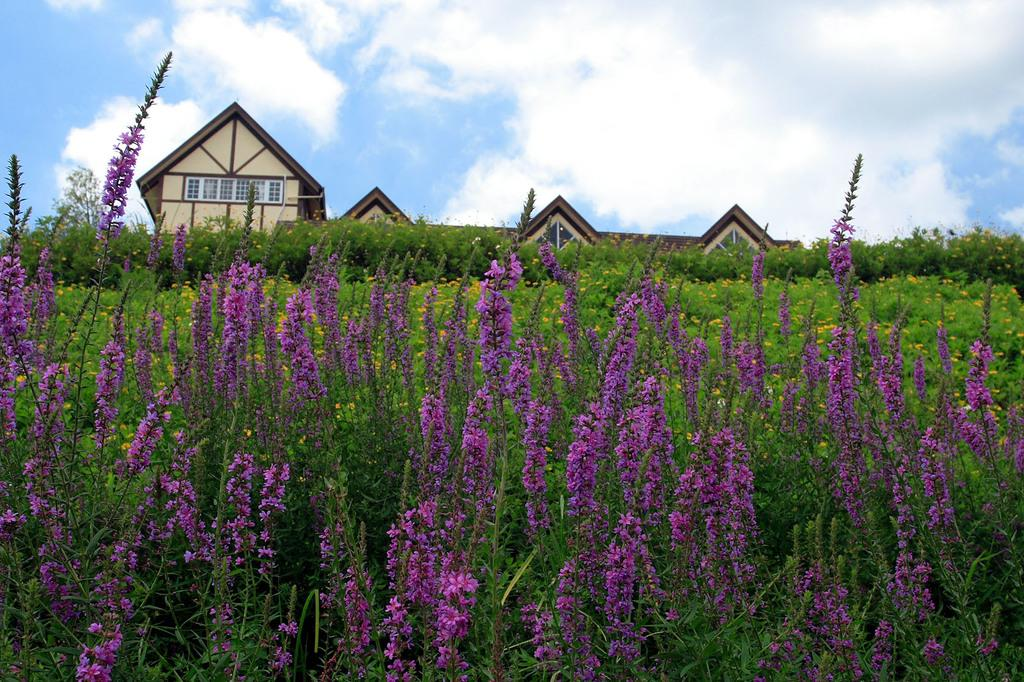What type of structure is present in the image? There is a building in the image. Can you describe any specific features of the building? There is a window visible in the image. What type of vegetation can be seen in the image? Tiny flowers, purple in color, are visible in the image. What else is present in the image besides the building and flowers? There is a plant in the image. How would you describe the sky in the image? The sky is cloudy and pale blue. What type of shirt is the baby wearing in the image? There is no baby or shirt present in the image. Can you tell me how many rats are visible in the image? There are no rats visible in the image. 